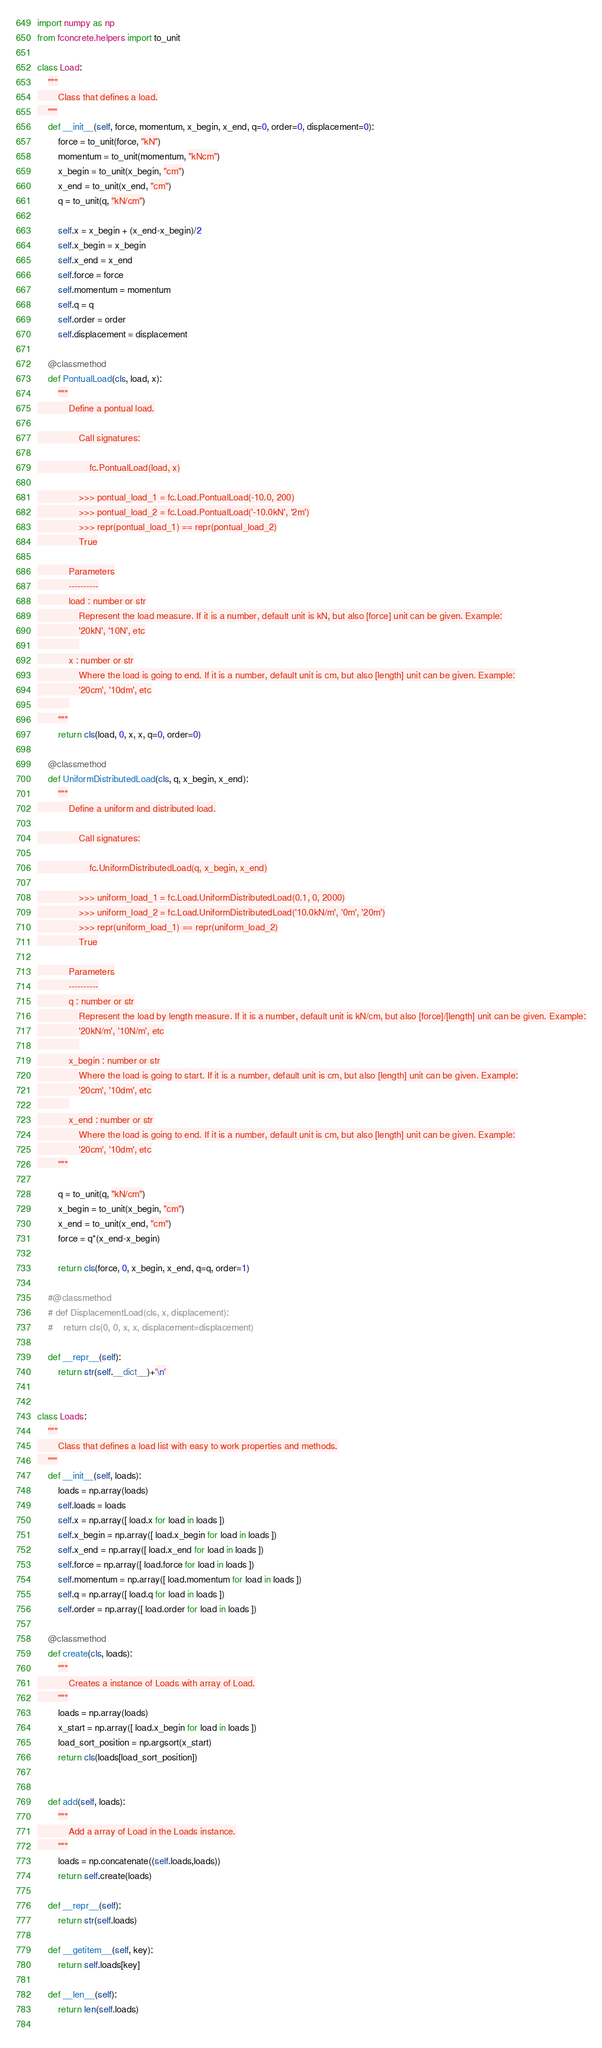Convert code to text. <code><loc_0><loc_0><loc_500><loc_500><_Python_>import numpy as np
from fconcrete.helpers import to_unit

class Load:
    """
        Class that defines a load.
    """
    def __init__(self, force, momentum, x_begin, x_end, q=0, order=0, displacement=0):
        force = to_unit(force, "kN")
        momentum = to_unit(momentum, "kNcm")
        x_begin = to_unit(x_begin, "cm")
        x_end = to_unit(x_end, "cm")
        q = to_unit(q, "kN/cm")
        
        self.x = x_begin + (x_end-x_begin)/2
        self.x_begin = x_begin
        self.x_end = x_end
        self.force = force
        self.momentum = momentum
        self.q = q
        self.order = order
        self.displacement = displacement
        
    @classmethod
    def PontualLoad(cls, load, x):
        """
            Define a pontual load.

                Call signatures:

                    fc.PontualLoad(load, x)

                >>> pontual_load_1 = fc.Load.PontualLoad(-10.0, 200)
                >>> pontual_load_2 = fc.Load.PontualLoad('-10.0kN', '2m')
                >>> repr(pontual_load_1) == repr(pontual_load_2)
                True

            Parameters
            ----------
            load : number or str
                Represent the load measure. If it is a number, default unit is kN, but also [force] unit can be given. Example:
                '20kN', '10N', etc
                
            x : number or str
                Where the load is going to end. If it is a number, default unit is cm, but also [length] unit can be given. Example:
                '20cm', '10dm', etc
            
        """ 
        return cls(load, 0, x, x, q=0, order=0)
    
    @classmethod
    def UniformDistributedLoad(cls, q, x_begin, x_end):
        """
            Define a uniform and distributed load.

                Call signatures:

                    fc.UniformDistributedLoad(q, x_begin, x_end)

                >>> uniform_load_1 = fc.Load.UniformDistributedLoad(0.1, 0, 2000)
                >>> uniform_load_2 = fc.Load.UniformDistributedLoad('10.0kN/m', '0m', '20m')
                >>> repr(uniform_load_1) == repr(uniform_load_2)
                True

            Parameters
            ----------
            q : number or str
                Represent the load by length measure. If it is a number, default unit is kN/cm, but also [force]/[length] unit can be given. Example:
                '20kN/m', '10N/m', etc
                
            x_begin : number or str
                Where the load is going to start. If it is a number, default unit is cm, but also [length] unit can be given. Example:
                '20cm', '10dm', etc
            
            x_end : number or str
                Where the load is going to end. If it is a number, default unit is cm, but also [length] unit can be given. Example:
                '20cm', '10dm', etc
        """ 
        
        q = to_unit(q, "kN/cm")
        x_begin = to_unit(x_begin, "cm")
        x_end = to_unit(x_end, "cm")
        force = q*(x_end-x_begin)
        
        return cls(force, 0, x_begin, x_end, q=q, order=1)
    
    #@classmethod
    # def DisplacementLoad(cls, x, displacement):
    #    return cls(0, 0, x, x, displacement=displacement)
    
    def __repr__(self):
        return str(self.__dict__)+'\n'


class Loads:
    """
        Class that defines a load list with easy to work properties and methods.
    """
    def __init__(self, loads):
        loads = np.array(loads)
        self.loads = loads
        self.x = np.array([ load.x for load in loads ])
        self.x_begin = np.array([ load.x_begin for load in loads ])
        self.x_end = np.array([ load.x_end for load in loads ])
        self.force = np.array([ load.force for load in loads ])
        self.momentum = np.array([ load.momentum for load in loads ])
        self.q = np.array([ load.q for load in loads ])
        self.order = np.array([ load.order for load in loads ])
    
    @classmethod
    def create(cls, loads):
        """
            Creates a instance of Loads with array of Load.
        """
        loads = np.array(loads)
        x_start = np.array([ load.x_begin for load in loads ])
        load_sort_position = np.argsort(x_start)
        return cls(loads[load_sort_position])
    
    
    def add(self, loads):
        """
            Add a array of Load in the Loads instance.
        """
        loads = np.concatenate((self.loads,loads))
        return self.create(loads)
    
    def __repr__(self):
        return str(self.loads)
     
    def __getitem__(self, key):
        return self.loads[key]
    
    def __len__(self):
        return len(self.loads)
    
</code> 